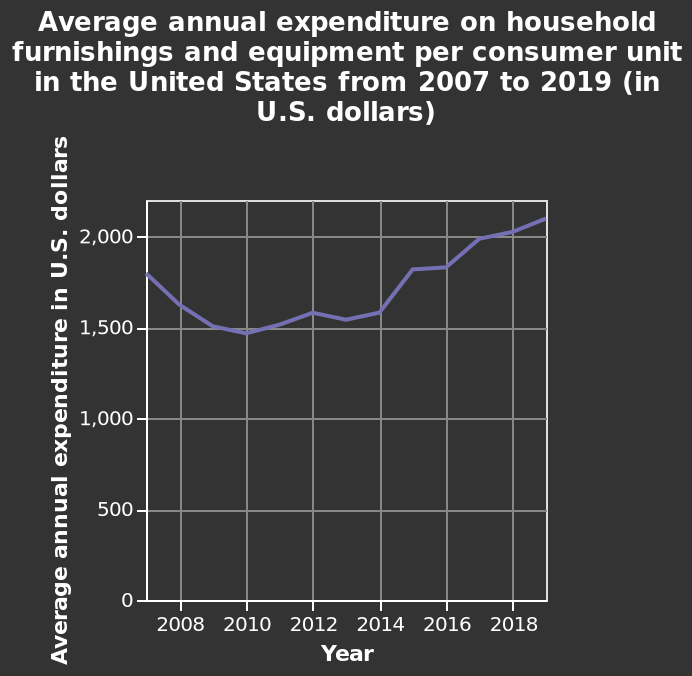<image>
please summary the statistics and relations of the chart I can't really tell any trends in this graph, sorry. What does the y-axis show in the line graph?  The y-axis shows Average annual expenditure in U.S. dollars. 